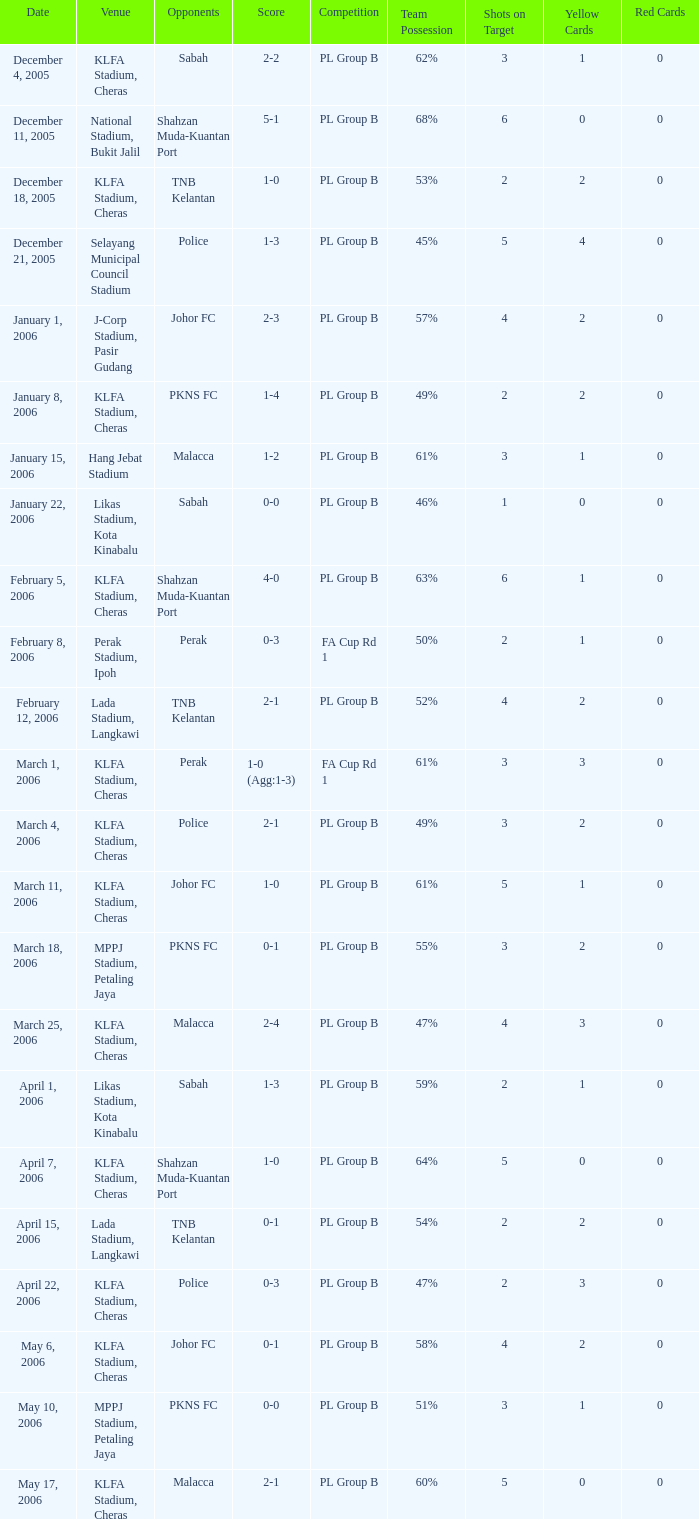Which Score has Opponents of pkns fc, and a Date of january 8, 2006? 1-4. 